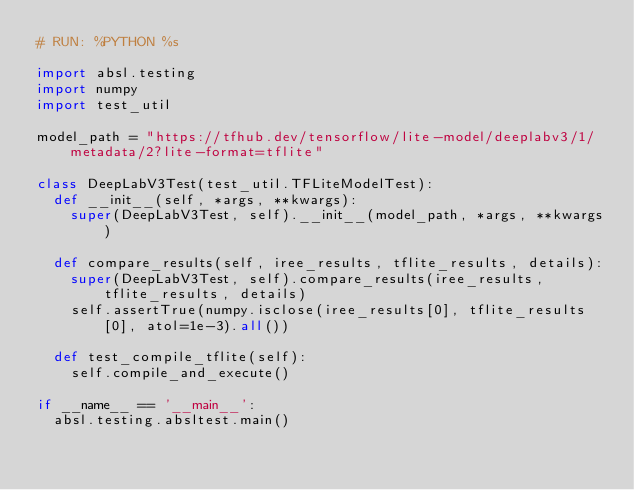<code> <loc_0><loc_0><loc_500><loc_500><_Python_># RUN: %PYTHON %s

import absl.testing
import numpy
import test_util

model_path = "https://tfhub.dev/tensorflow/lite-model/deeplabv3/1/metadata/2?lite-format=tflite"

class DeepLabV3Test(test_util.TFLiteModelTest):
  def __init__(self, *args, **kwargs):
    super(DeepLabV3Test, self).__init__(model_path, *args, **kwargs)

  def compare_results(self, iree_results, tflite_results, details):
    super(DeepLabV3Test, self).compare_results(iree_results, tflite_results, details)
    self.assertTrue(numpy.isclose(iree_results[0], tflite_results[0], atol=1e-3).all())

  def test_compile_tflite(self):
    self.compile_and_execute()

if __name__ == '__main__':
  absl.testing.absltest.main()

</code> 